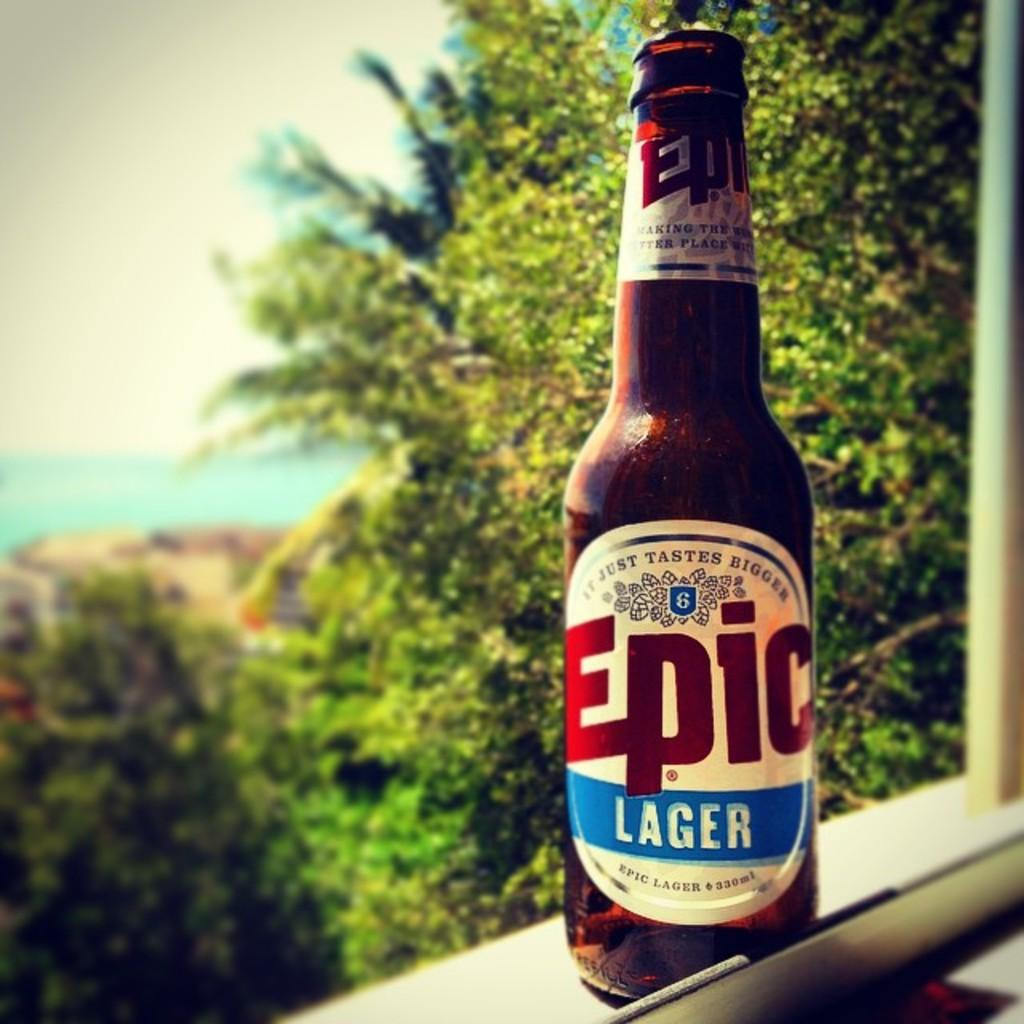What is the main object in the image? There is a beer bottle in the image. Where is the beer bottle located? The beer bottle is on a window. What can be seen in the background of the image? There are trees visible in the back side of the image. How many ladybugs are crawling on the beer bottle in the image? There are no ladybugs present on the beer bottle in the image. What type of chain is holding the beer bottle to the window? There is no chain visible in the image; the beer bottle is simply placed on the window. 